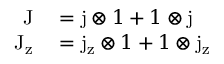Convert formula to latex. <formula><loc_0><loc_0><loc_500><loc_500>\begin{array} { r l } { J } & = j \otimes 1 + 1 \otimes j } \\ { J _ { z } } & = j _ { z } \otimes 1 + 1 \otimes j _ { z } } \end{array}</formula> 